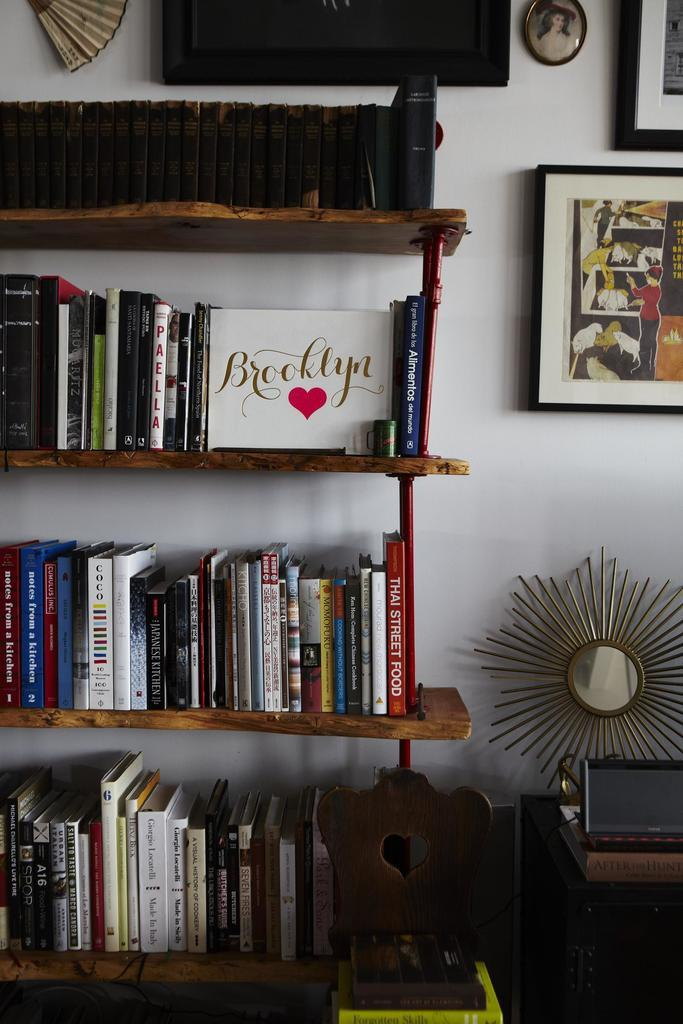What is the main object in the image? There is a rack in the image. What is on the rack? There are books on the rack. What can be seen on the wall in the image? There is a photo frame on the wall. Can you describe the background of the image? The background of the image includes a wall. What type of engine can be seen in the image? There is no engine present in the image. What kind of pancake is being served in the photo frame? There is no pancake visible in the image, and the photo frame does not depict any food. 